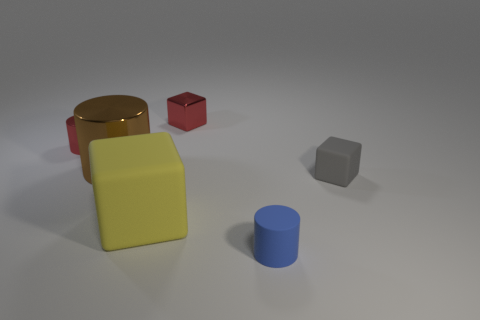There is a matte block that is right of the tiny cube that is behind the tiny shiny thing to the left of the brown object; what color is it?
Your answer should be very brief. Gray. How many large things are gray metal cylinders or gray rubber blocks?
Provide a short and direct response. 0. Is the number of small gray cubes that are on the right side of the gray matte cube the same as the number of big red matte cylinders?
Make the answer very short. Yes. There is a red block; are there any tiny cylinders to the left of it?
Your answer should be very brief. Yes. What number of rubber things are large gray cylinders or large brown things?
Provide a short and direct response. 0. There is a yellow rubber thing; what number of red things are on the right side of it?
Ensure brevity in your answer.  1. Are there any matte cubes that have the same size as the blue matte object?
Your answer should be compact. Yes. Is there a tiny thing that has the same color as the large rubber cube?
Make the answer very short. No. How many tiny things are the same color as the small shiny block?
Your answer should be compact. 1. There is a tiny matte cube; does it have the same color as the small thing in front of the yellow object?
Offer a terse response. No. 